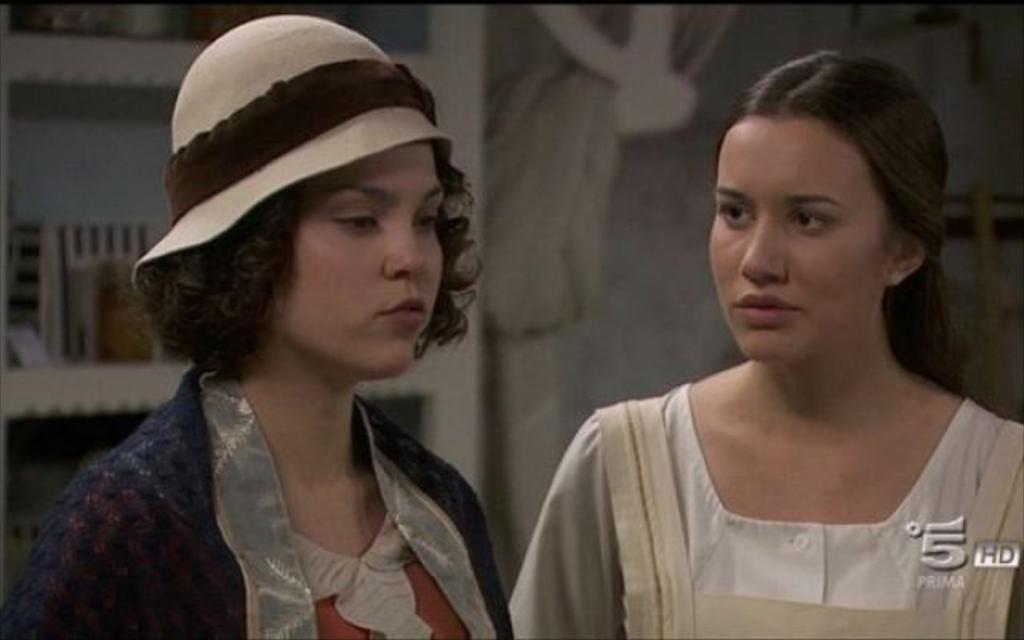Could you give a brief overview of what you see in this image? Here I can see two women. The woman who is on the right side is looking at the other woman. The woman who is on the left side is wearing a cap on the head and looking at the right side. In the background there is a wall. On the left side there is a rack in which few objects are placed. 